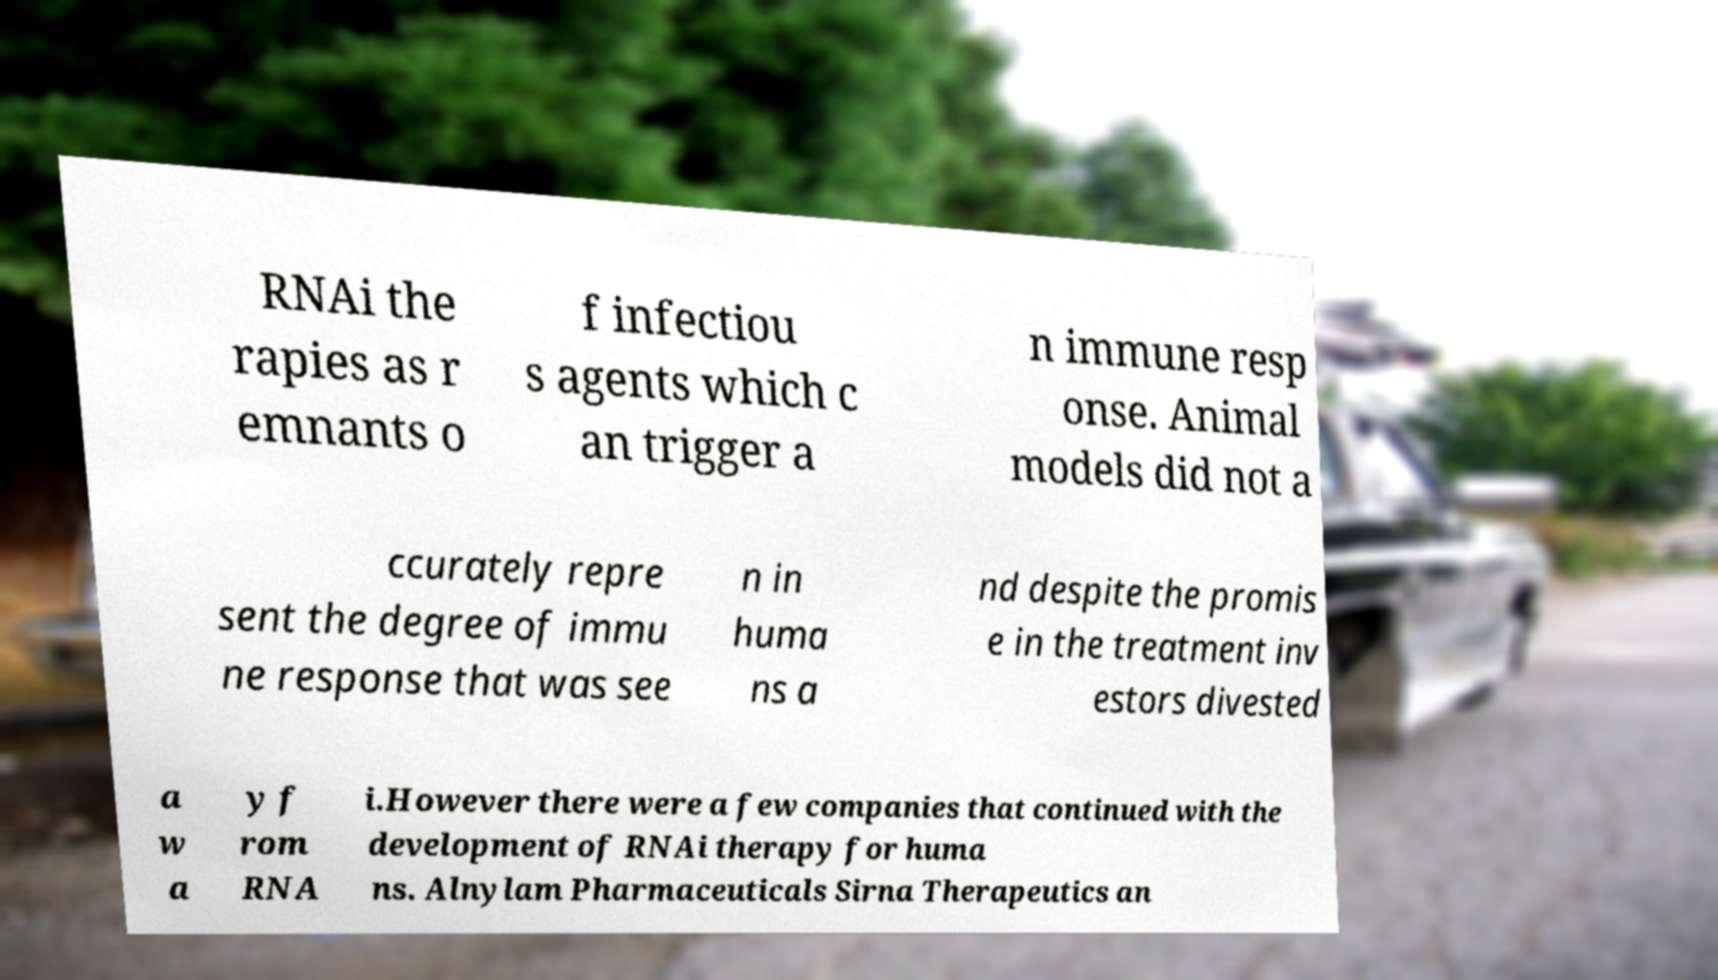Can you read and provide the text displayed in the image?This photo seems to have some interesting text. Can you extract and type it out for me? RNAi the rapies as r emnants o f infectiou s agents which c an trigger a n immune resp onse. Animal models did not a ccurately repre sent the degree of immu ne response that was see n in huma ns a nd despite the promis e in the treatment inv estors divested a w a y f rom RNA i.However there were a few companies that continued with the development of RNAi therapy for huma ns. Alnylam Pharmaceuticals Sirna Therapeutics an 